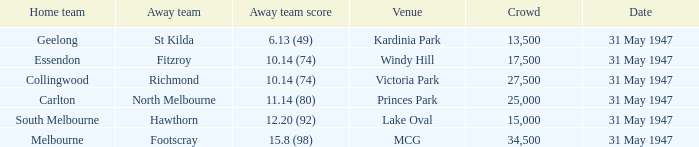What is the specified gathering when hawthorn is absent? 1.0. 